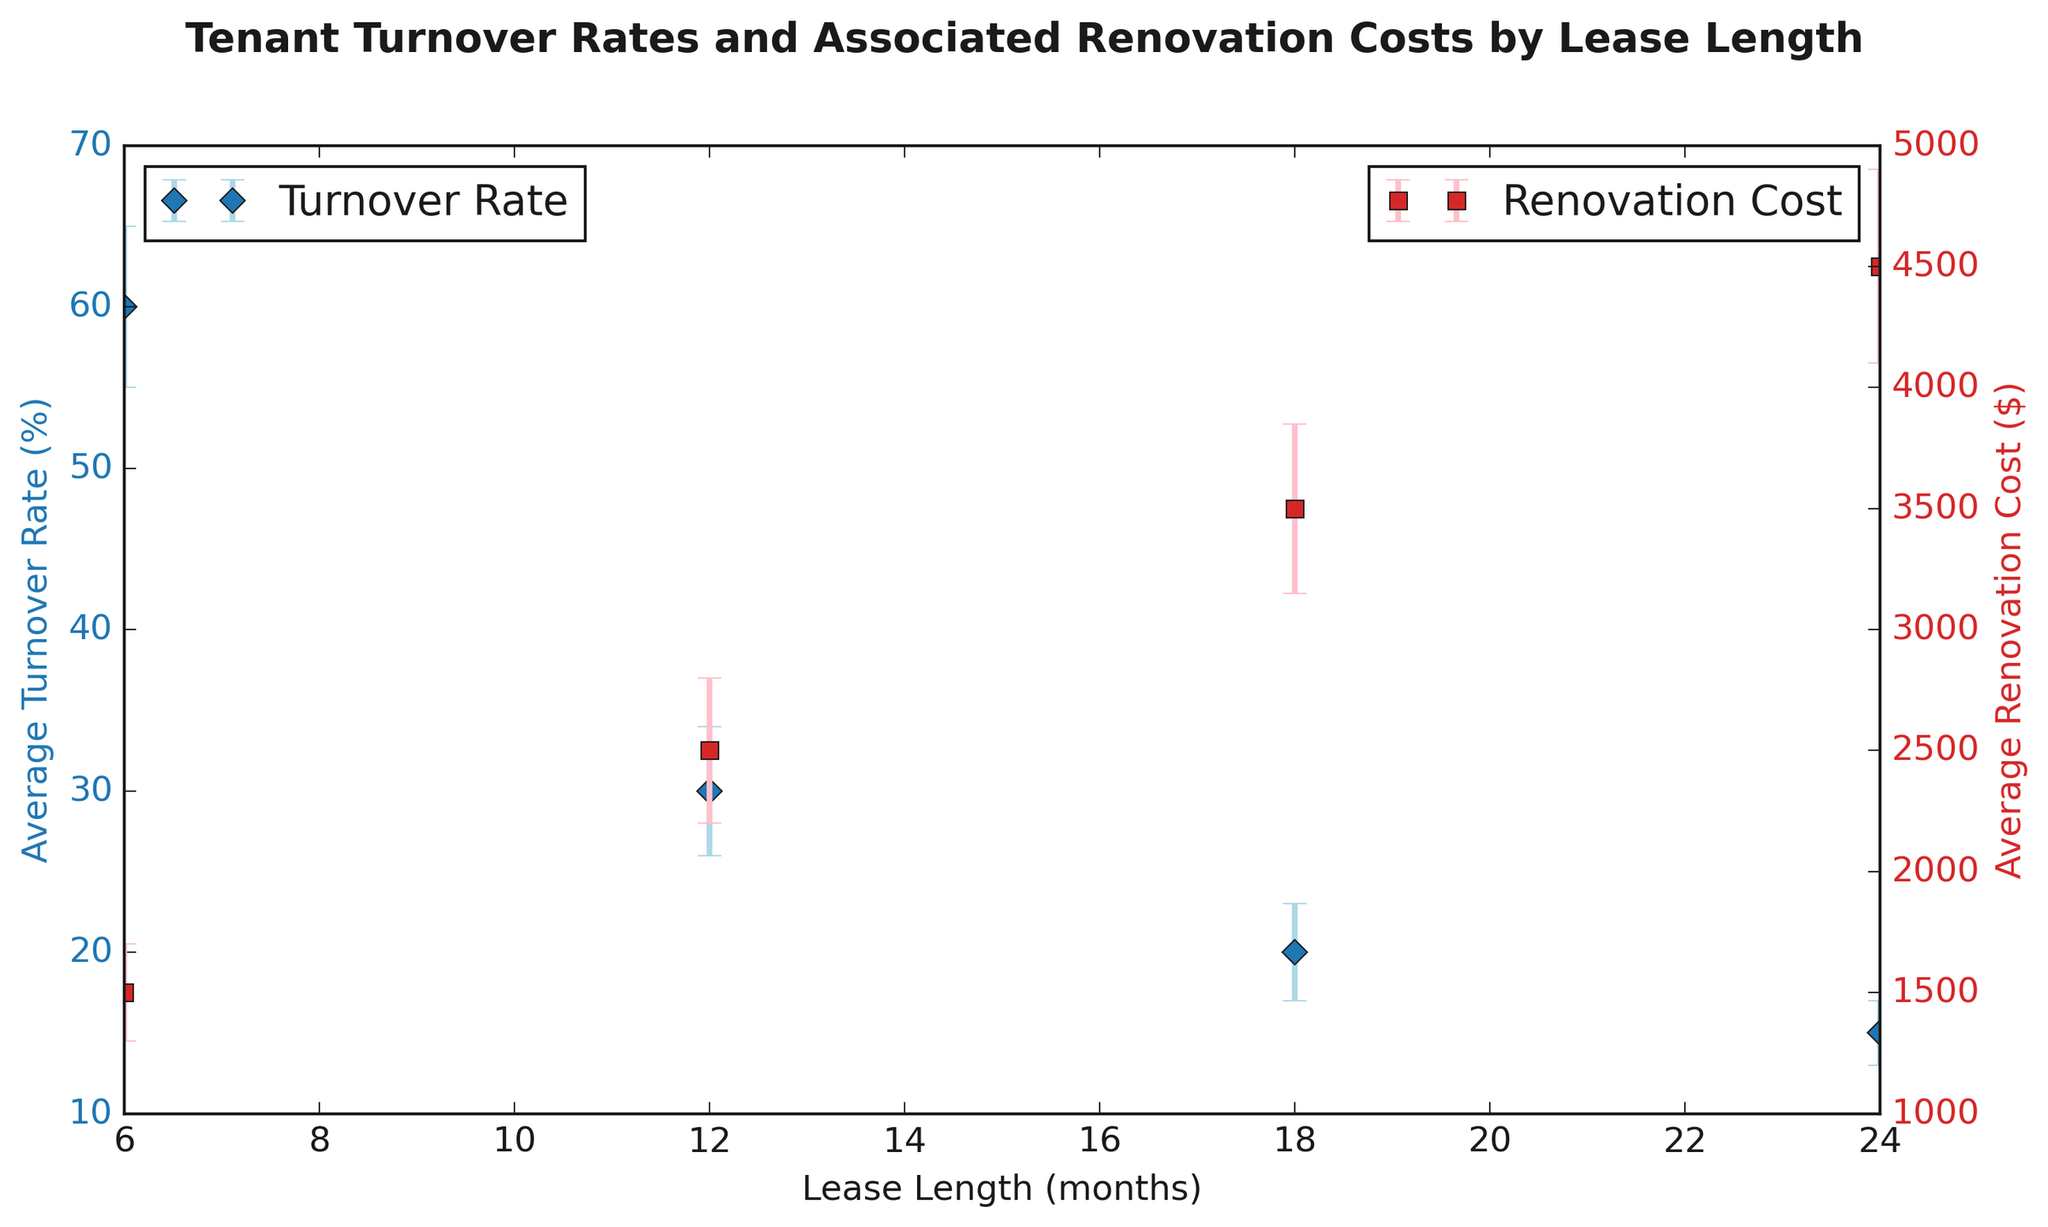What is the range of the Average Turnover Rates for all lease lengths? The average turnover rates are given for each lease length. The highest rate is 60% (for 6 months) and the lowest is 15% (for 24 months). The range is the difference between the highest and lowest values: 60 - 15 = 45%.
Answer: 45% Which lease length has the lowest Average Renovation Cost? By comparing the renovation costs for all lease lengths, the lowest average renovation cost is $1500, which corresponds to the 6-month lease length.
Answer: 6 months What is the difference in Average Turnover Rate between the 6-month and 24-month lease lengths? The Average Turnover Rate for 6 months is 60%, and for 24 months it is 15%. The difference between these rates is 60 - 15 = 45%.
Answer: 45% How do the Average Renovation Costs compare between the 12-month and 18-month lease lengths? The Average Renovation Cost for a 12-month lease is $2500 and for an 18-month lease is $3500. The 18-month lease has a higher renovation cost.
Answer: 18-month lease is higher Which data series is represented by blue markers? The figure uses blue markers for Average Turnover Rate.
Answer: Average Turnover Rate What is the total Average Renovation Cost for all lease lengths combined? Add the average renovation costs for 6, 12, 18, and 24 months: 1500 + 2500 + 3500 + 4500 = 12000.
Answer: $12000 Is the Turnover Rate Standard Deviation higher for the shortest or longest lease length? The turnover rate standard deviation for the shortest lease length (6 months) is 5%, and for the longest lease length (24 months) it is 2%. Therefore, it is higher for the shortest lease length.
Answer: Shortest lease length Which lease length has the largest standard deviation in Average Renovation Cost? By comparing the renovation cost standard deviations, the largest is $400, which corresponds to the 24-month lease length.
Answer: 24 months What is the Combined Standard Deviation (Turnover Rate and Renovation Cost) for the 18-month lease length? Sum the standard deviations of the turnover rate and renovation cost for the 18-month lease length: 3 (Turnover Rate STD) + 350 (Renovation Cost STD) = 353.
Answer: 353 